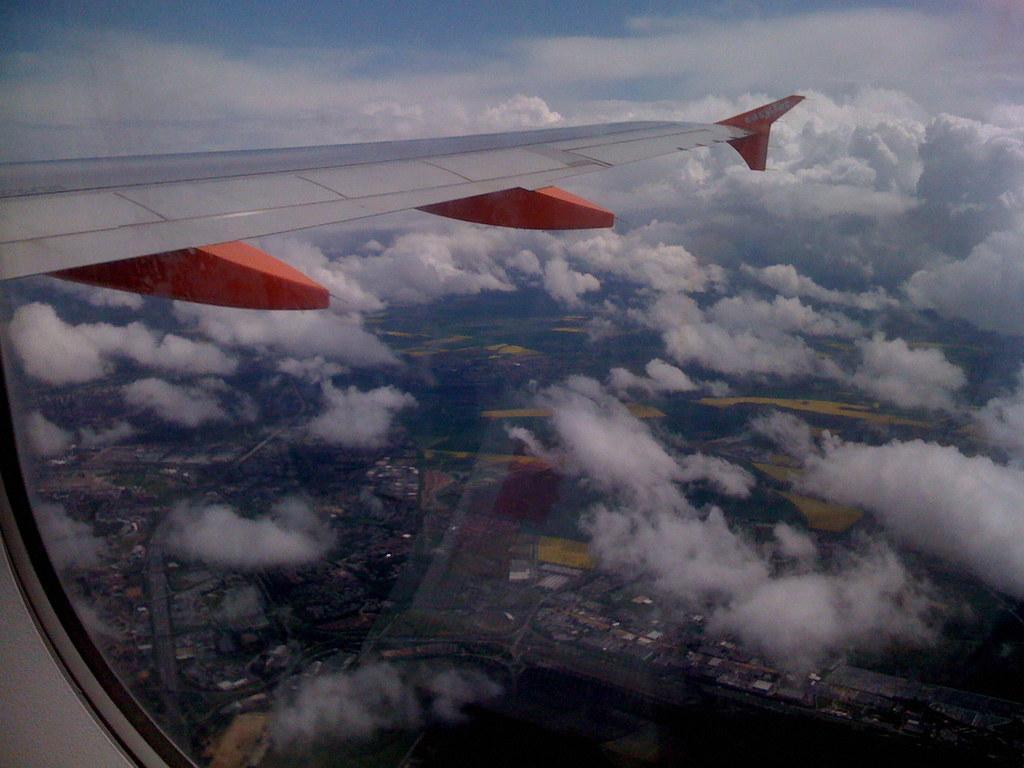Describe this image in one or two sentences. This image is taken from airplane, in this image there are clouds, at the bottom there are houses and trees. 